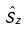Convert formula to latex. <formula><loc_0><loc_0><loc_500><loc_500>\hat { S } _ { z }</formula> 